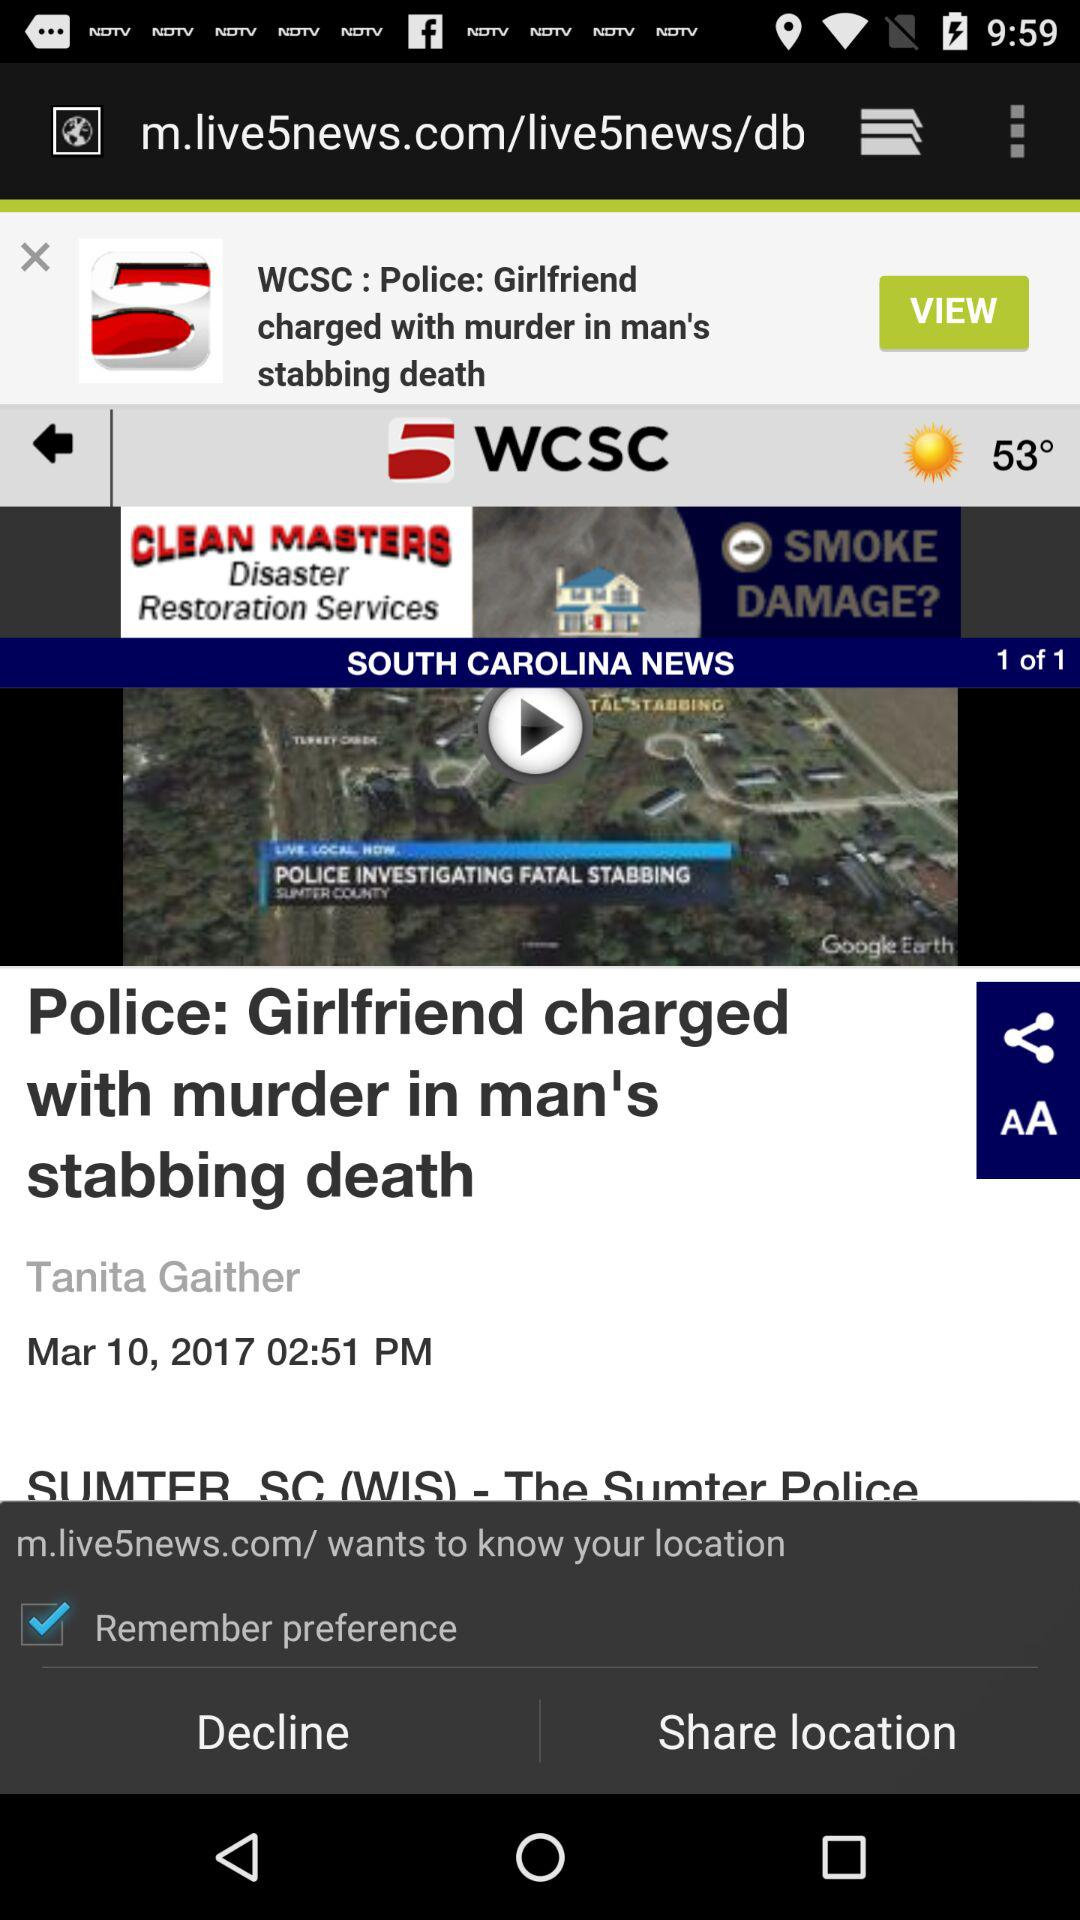What is the temperature? The temperature is 53 degrees. 